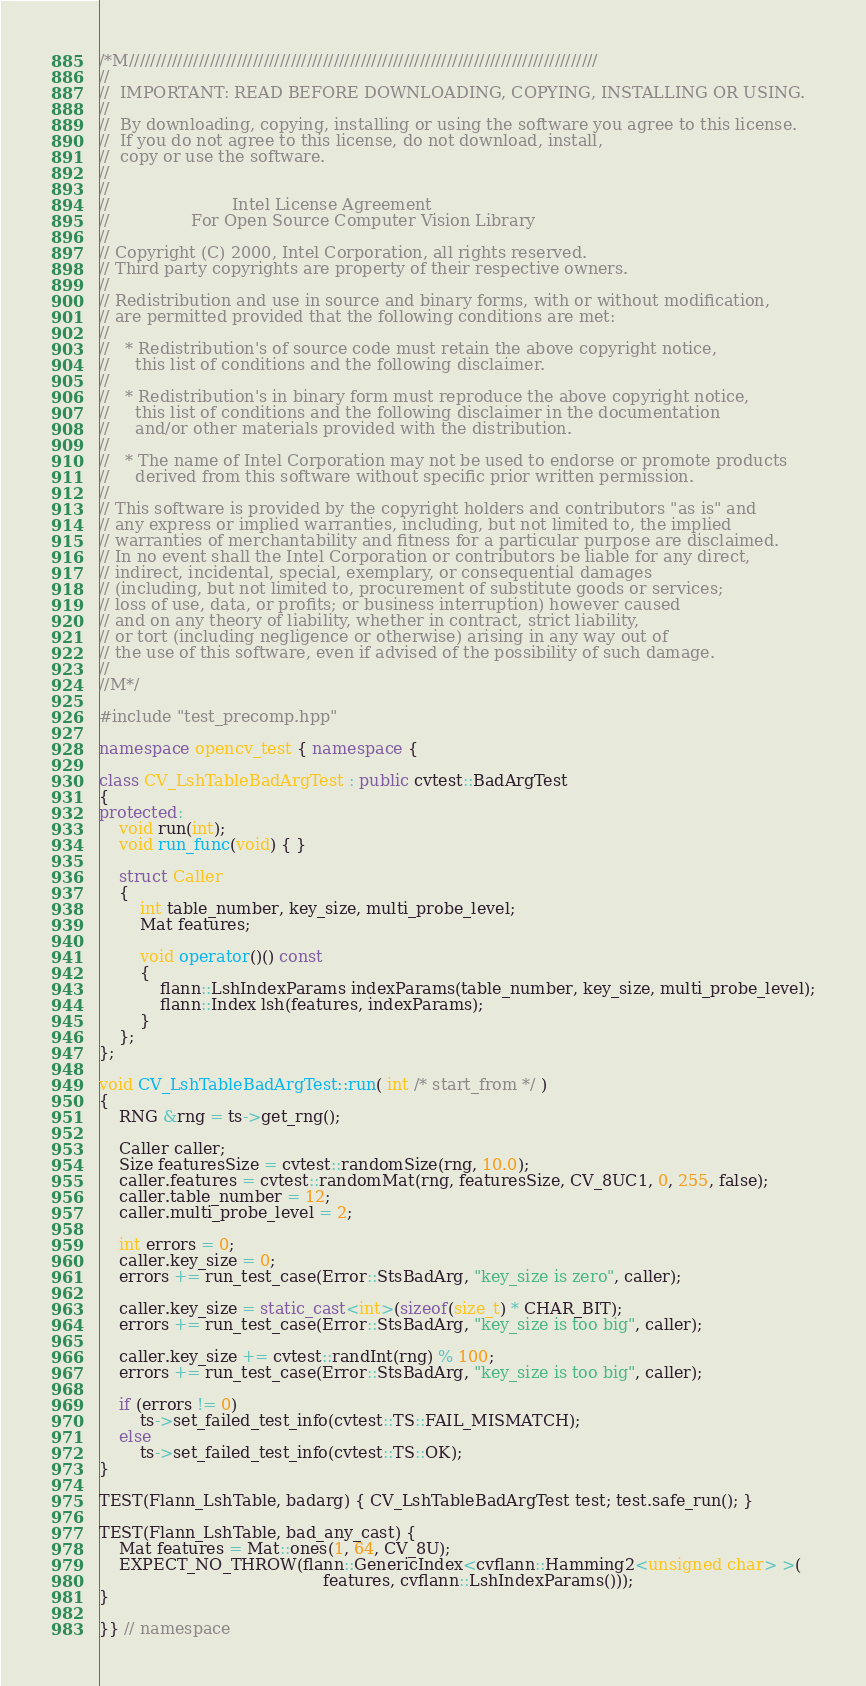Convert code to text. <code><loc_0><loc_0><loc_500><loc_500><_C++_>/*M///////////////////////////////////////////////////////////////////////////////////////
//
//  IMPORTANT: READ BEFORE DOWNLOADING, COPYING, INSTALLING OR USING.
//
//  By downloading, copying, installing or using the software you agree to this license.
//  If you do not agree to this license, do not download, install,
//  copy or use the software.
//
//
//                        Intel License Agreement
//                For Open Source Computer Vision Library
//
// Copyright (C) 2000, Intel Corporation, all rights reserved.
// Third party copyrights are property of their respective owners.
//
// Redistribution and use in source and binary forms, with or without modification,
// are permitted provided that the following conditions are met:
//
//   * Redistribution's of source code must retain the above copyright notice,
//     this list of conditions and the following disclaimer.
//
//   * Redistribution's in binary form must reproduce the above copyright notice,
//     this list of conditions and the following disclaimer in the documentation
//     and/or other materials provided with the distribution.
//
//   * The name of Intel Corporation may not be used to endorse or promote products
//     derived from this software without specific prior written permission.
//
// This software is provided by the copyright holders and contributors "as is" and
// any express or implied warranties, including, but not limited to, the implied
// warranties of merchantability and fitness for a particular purpose are disclaimed.
// In no event shall the Intel Corporation or contributors be liable for any direct,
// indirect, incidental, special, exemplary, or consequential damages
// (including, but not limited to, procurement of substitute goods or services;
// loss of use, data, or profits; or business interruption) however caused
// and on any theory of liability, whether in contract, strict liability,
// or tort (including negligence or otherwise) arising in any way out of
// the use of this software, even if advised of the possibility of such damage.
//
//M*/

#include "test_precomp.hpp"

namespace opencv_test { namespace {

class CV_LshTableBadArgTest : public cvtest::BadArgTest
{
protected:
    void run(int);
    void run_func(void) { }

    struct Caller
    {
        int table_number, key_size, multi_probe_level;
        Mat features;

        void operator()() const
        {
            flann::LshIndexParams indexParams(table_number, key_size, multi_probe_level);
            flann::Index lsh(features, indexParams);
        }
    };
};

void CV_LshTableBadArgTest::run( int /* start_from */ )
{
    RNG &rng = ts->get_rng();

    Caller caller;
    Size featuresSize = cvtest::randomSize(rng, 10.0);
    caller.features = cvtest::randomMat(rng, featuresSize, CV_8UC1, 0, 255, false);
    caller.table_number = 12;
    caller.multi_probe_level = 2;

    int errors = 0;
    caller.key_size = 0;
    errors += run_test_case(Error::StsBadArg, "key_size is zero", caller);

    caller.key_size = static_cast<int>(sizeof(size_t) * CHAR_BIT);
    errors += run_test_case(Error::StsBadArg, "key_size is too big", caller);

    caller.key_size += cvtest::randInt(rng) % 100;
    errors += run_test_case(Error::StsBadArg, "key_size is too big", caller);

    if (errors != 0)
        ts->set_failed_test_info(cvtest::TS::FAIL_MISMATCH);
    else
        ts->set_failed_test_info(cvtest::TS::OK);
}

TEST(Flann_LshTable, badarg) { CV_LshTableBadArgTest test; test.safe_run(); }

TEST(Flann_LshTable, bad_any_cast) {
    Mat features = Mat::ones(1, 64, CV_8U);
    EXPECT_NO_THROW(flann::GenericIndex<cvflann::Hamming2<unsigned char> >(
                                            features, cvflann::LshIndexParams()));
}

}} // namespace
</code> 